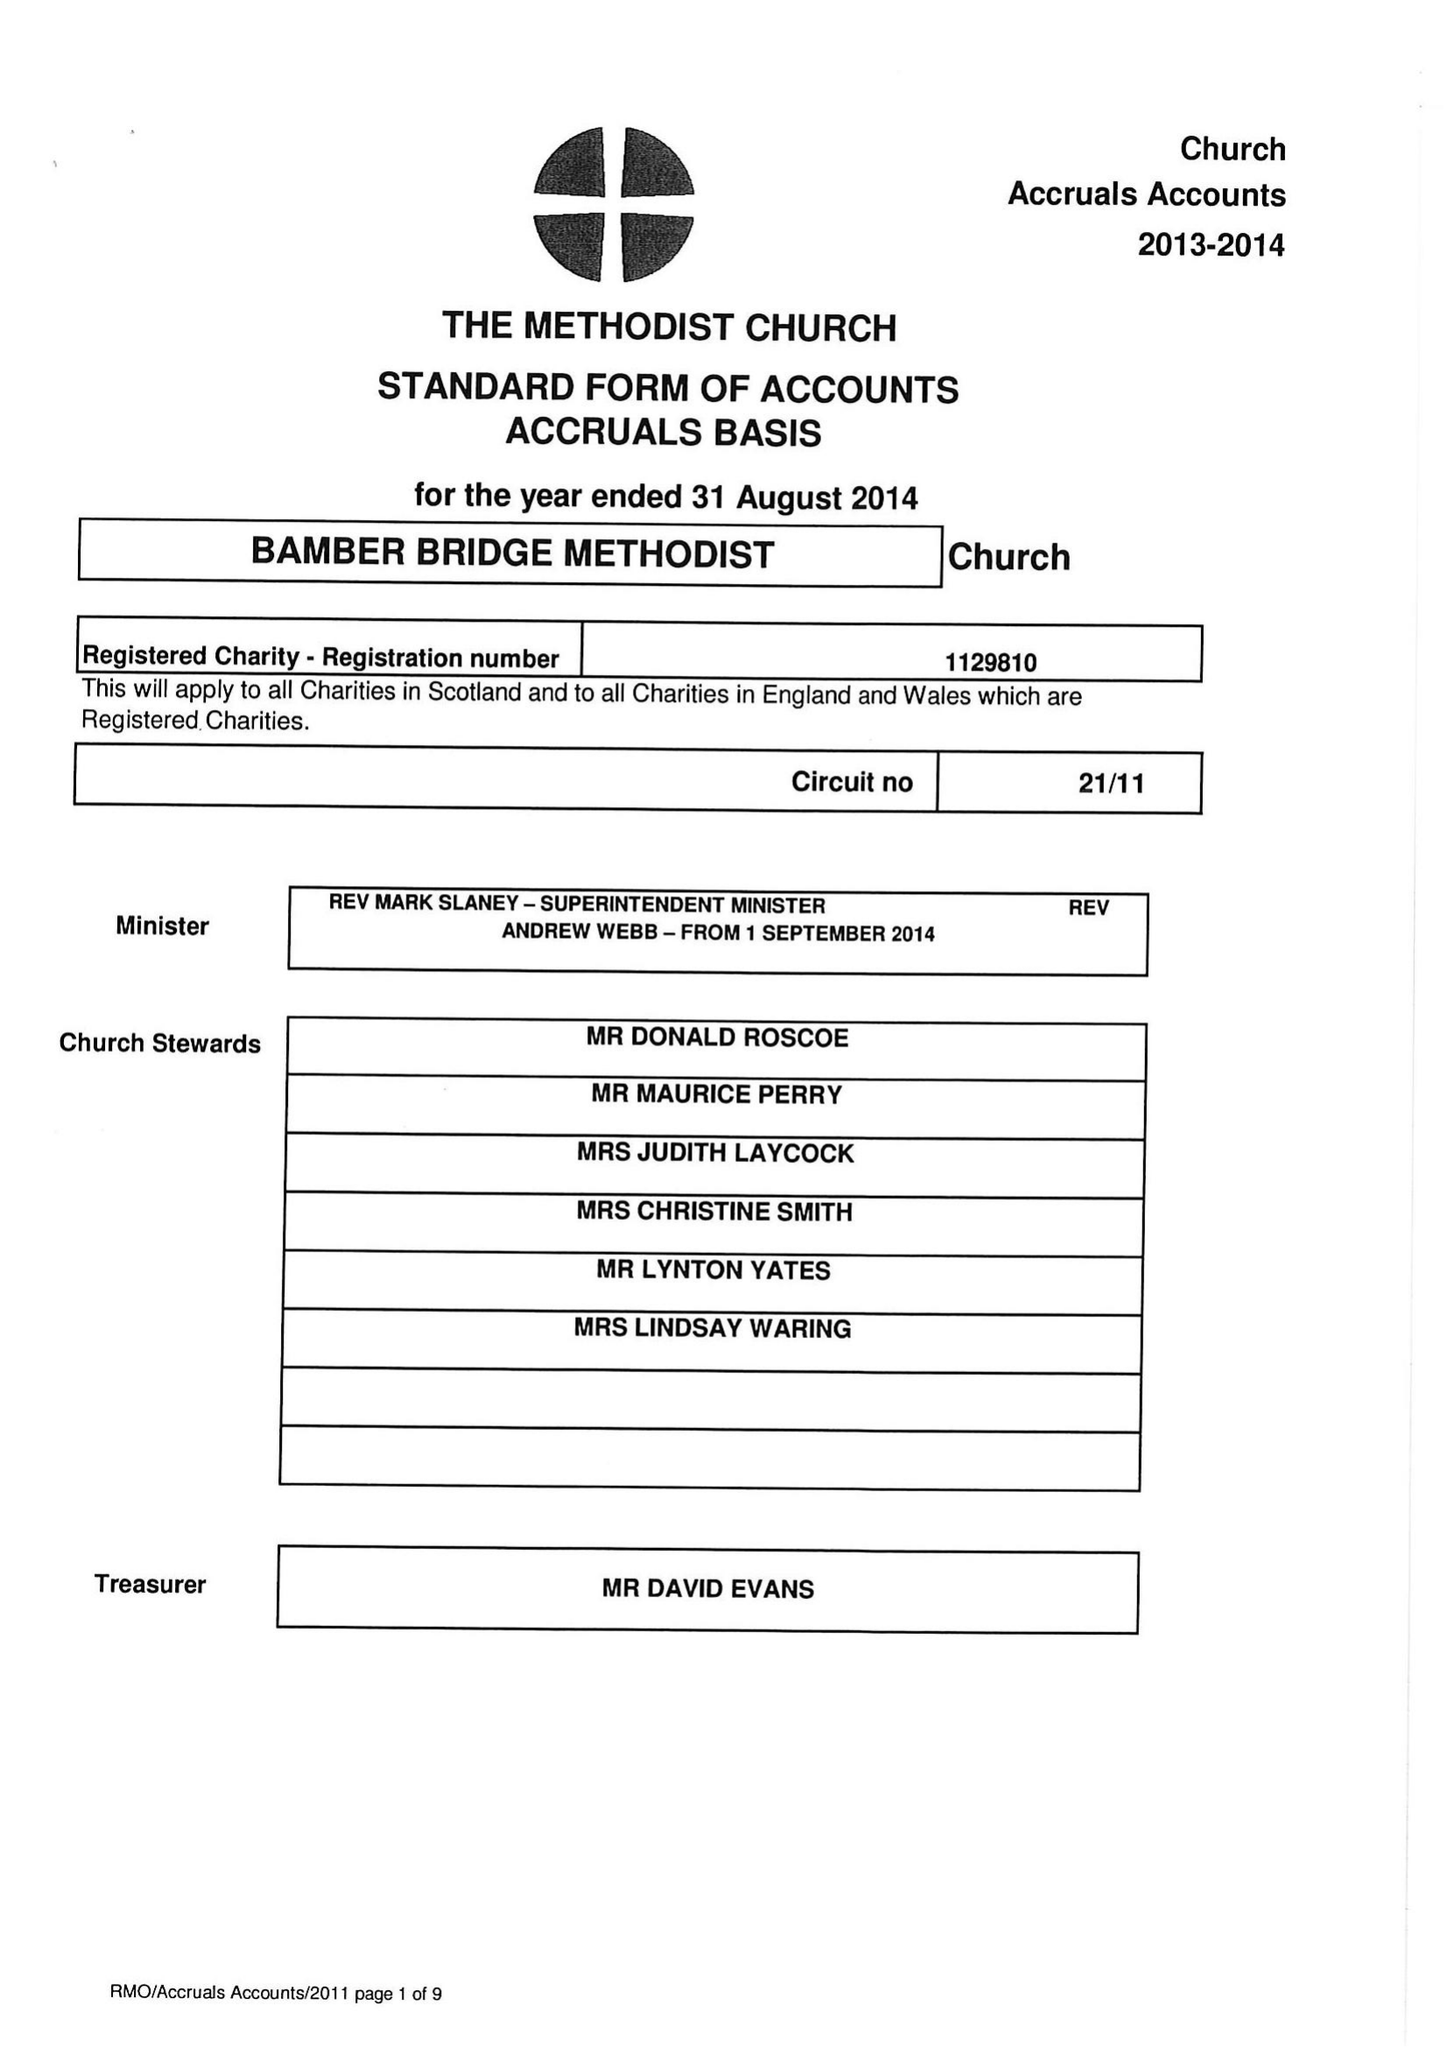What is the value for the income_annually_in_british_pounds?
Answer the question using a single word or phrase. 84129.00 